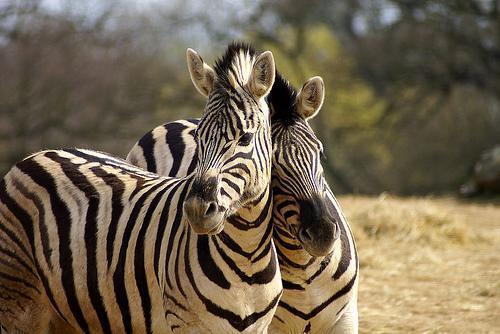How many zebras are there?
Give a very brief answer. 2. 